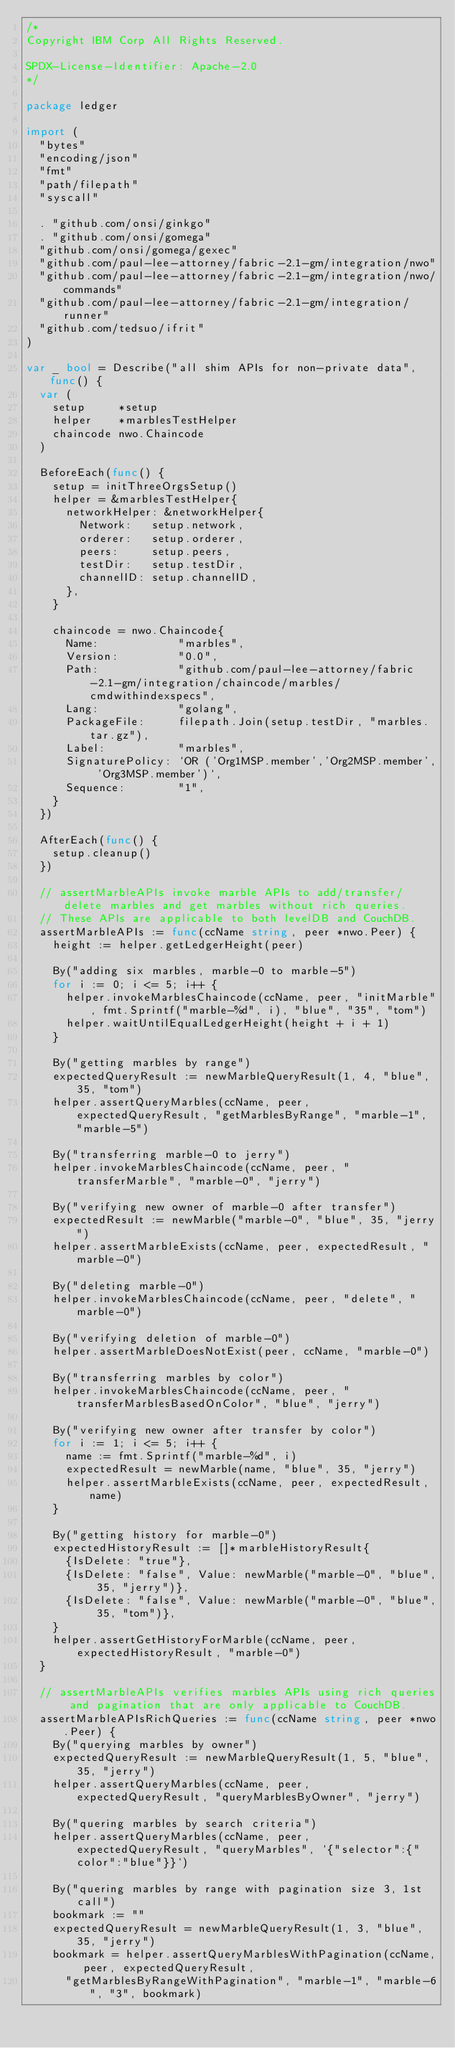<code> <loc_0><loc_0><loc_500><loc_500><_Go_>/*
Copyright IBM Corp All Rights Reserved.

SPDX-License-Identifier: Apache-2.0
*/

package ledger

import (
	"bytes"
	"encoding/json"
	"fmt"
	"path/filepath"
	"syscall"

	. "github.com/onsi/ginkgo"
	. "github.com/onsi/gomega"
	"github.com/onsi/gomega/gexec"
	"github.com/paul-lee-attorney/fabric-2.1-gm/integration/nwo"
	"github.com/paul-lee-attorney/fabric-2.1-gm/integration/nwo/commands"
	"github.com/paul-lee-attorney/fabric-2.1-gm/integration/runner"
	"github.com/tedsuo/ifrit"
)

var _ bool = Describe("all shim APIs for non-private data", func() {
	var (
		setup     *setup
		helper    *marblesTestHelper
		chaincode nwo.Chaincode
	)

	BeforeEach(func() {
		setup = initThreeOrgsSetup()
		helper = &marblesTestHelper{
			networkHelper: &networkHelper{
				Network:   setup.network,
				orderer:   setup.orderer,
				peers:     setup.peers,
				testDir:   setup.testDir,
				channelID: setup.channelID,
			},
		}

		chaincode = nwo.Chaincode{
			Name:            "marbles",
			Version:         "0.0",
			Path:            "github.com/paul-lee-attorney/fabric-2.1-gm/integration/chaincode/marbles/cmdwithindexspecs",
			Lang:            "golang",
			PackageFile:     filepath.Join(setup.testDir, "marbles.tar.gz"),
			Label:           "marbles",
			SignaturePolicy: `OR ('Org1MSP.member','Org2MSP.member', 'Org3MSP.member')`,
			Sequence:        "1",
		}
	})

	AfterEach(func() {
		setup.cleanup()
	})

	// assertMarbleAPIs invoke marble APIs to add/transfer/delete marbles and get marbles without rich queries.
	// These APIs are applicable to both levelDB and CouchDB.
	assertMarbleAPIs := func(ccName string, peer *nwo.Peer) {
		height := helper.getLedgerHeight(peer)

		By("adding six marbles, marble-0 to marble-5")
		for i := 0; i <= 5; i++ {
			helper.invokeMarblesChaincode(ccName, peer, "initMarble", fmt.Sprintf("marble-%d", i), "blue", "35", "tom")
			helper.waitUntilEqualLedgerHeight(height + i + 1)
		}

		By("getting marbles by range")
		expectedQueryResult := newMarbleQueryResult(1, 4, "blue", 35, "tom")
		helper.assertQueryMarbles(ccName, peer, expectedQueryResult, "getMarblesByRange", "marble-1", "marble-5")

		By("transferring marble-0 to jerry")
		helper.invokeMarblesChaincode(ccName, peer, "transferMarble", "marble-0", "jerry")

		By("verifying new owner of marble-0 after transfer")
		expectedResult := newMarble("marble-0", "blue", 35, "jerry")
		helper.assertMarbleExists(ccName, peer, expectedResult, "marble-0")

		By("deleting marble-0")
		helper.invokeMarblesChaincode(ccName, peer, "delete", "marble-0")

		By("verifying deletion of marble-0")
		helper.assertMarbleDoesNotExist(peer, ccName, "marble-0")

		By("transferring marbles by color")
		helper.invokeMarblesChaincode(ccName, peer, "transferMarblesBasedOnColor", "blue", "jerry")

		By("verifying new owner after transfer by color")
		for i := 1; i <= 5; i++ {
			name := fmt.Sprintf("marble-%d", i)
			expectedResult = newMarble(name, "blue", 35, "jerry")
			helper.assertMarbleExists(ccName, peer, expectedResult, name)
		}

		By("getting history for marble-0")
		expectedHistoryResult := []*marbleHistoryResult{
			{IsDelete: "true"},
			{IsDelete: "false", Value: newMarble("marble-0", "blue", 35, "jerry")},
			{IsDelete: "false", Value: newMarble("marble-0", "blue", 35, "tom")},
		}
		helper.assertGetHistoryForMarble(ccName, peer, expectedHistoryResult, "marble-0")
	}

	// assertMarbleAPIs verifies marbles APIs using rich queries and pagination that are only applicable to CouchDB.
	assertMarbleAPIsRichQueries := func(ccName string, peer *nwo.Peer) {
		By("querying marbles by owner")
		expectedQueryResult := newMarbleQueryResult(1, 5, "blue", 35, "jerry")
		helper.assertQueryMarbles(ccName, peer, expectedQueryResult, "queryMarblesByOwner", "jerry")

		By("quering marbles by search criteria")
		helper.assertQueryMarbles(ccName, peer, expectedQueryResult, "queryMarbles", `{"selector":{"color":"blue"}}`)

		By("quering marbles by range with pagination size 3, 1st call")
		bookmark := ""
		expectedQueryResult = newMarbleQueryResult(1, 3, "blue", 35, "jerry")
		bookmark = helper.assertQueryMarblesWithPagination(ccName, peer, expectedQueryResult,
			"getMarblesByRangeWithPagination", "marble-1", "marble-6", "3", bookmark)
</code> 